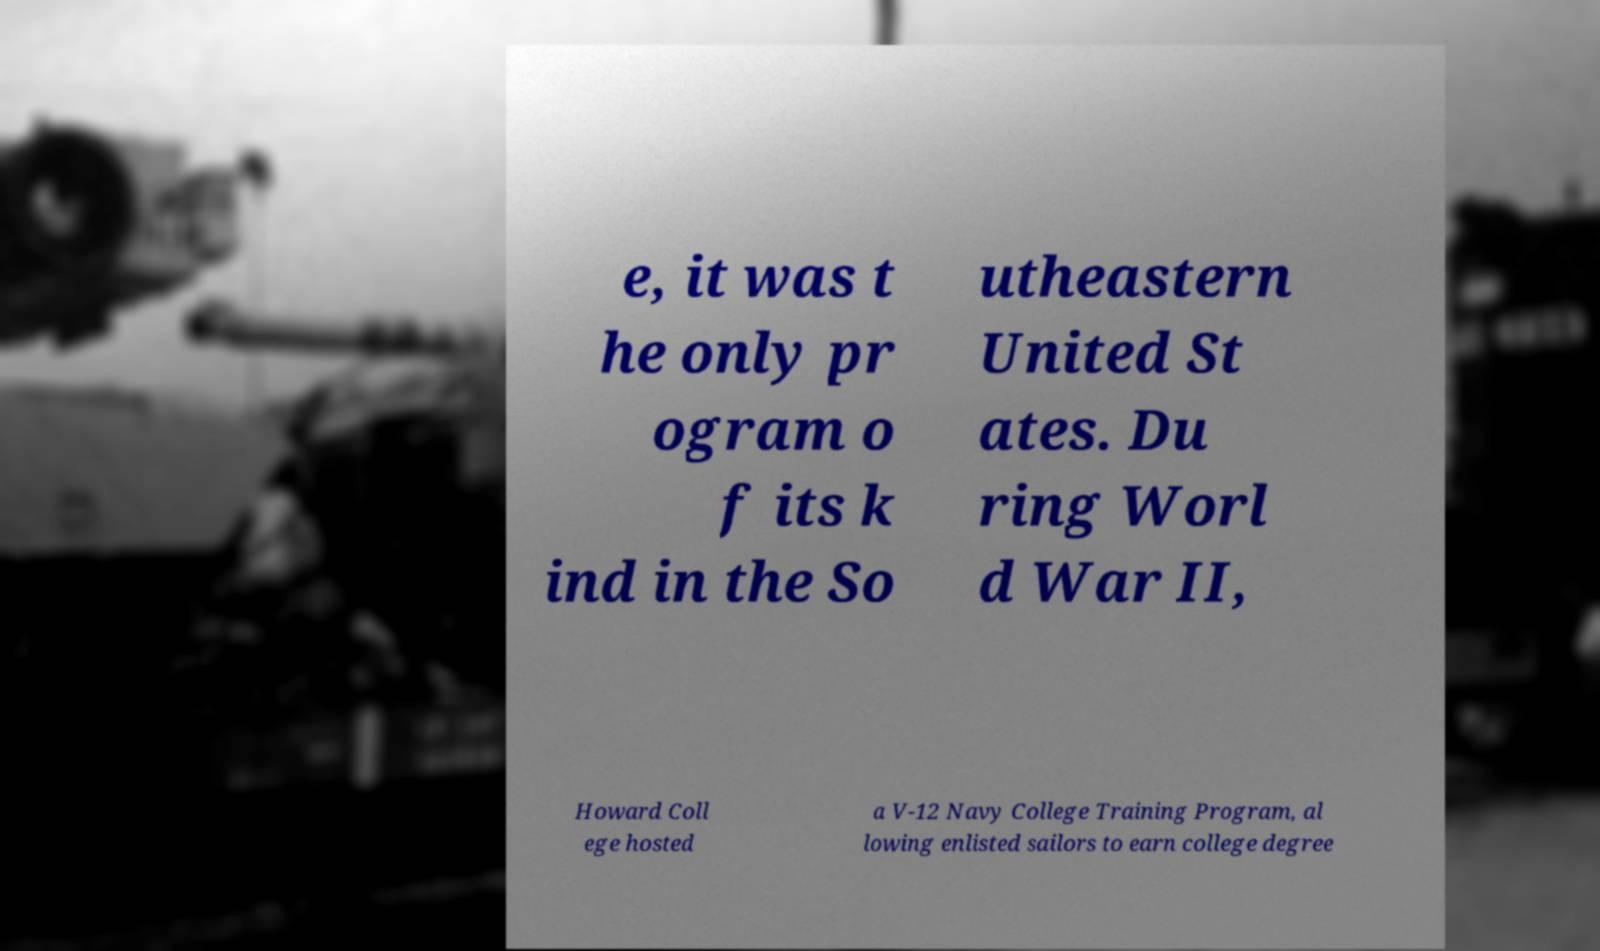Can you read and provide the text displayed in the image?This photo seems to have some interesting text. Can you extract and type it out for me? e, it was t he only pr ogram o f its k ind in the So utheastern United St ates. Du ring Worl d War II, Howard Coll ege hosted a V-12 Navy College Training Program, al lowing enlisted sailors to earn college degree 